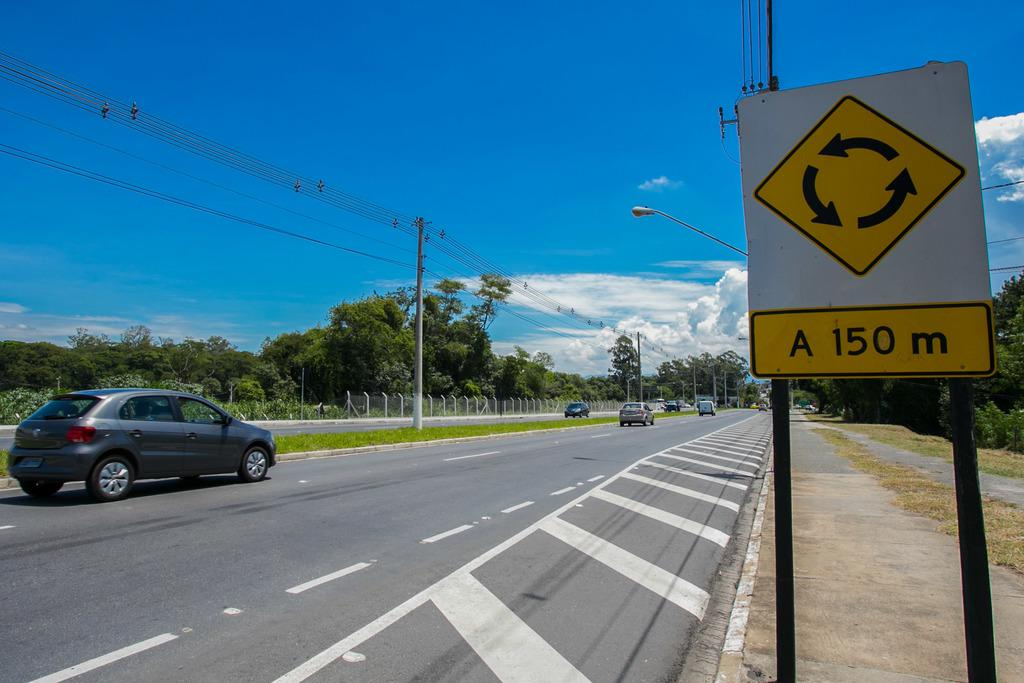Provide a one-sentence caption for the provided image. A sign says a roundabout is 150 meters ahead. 